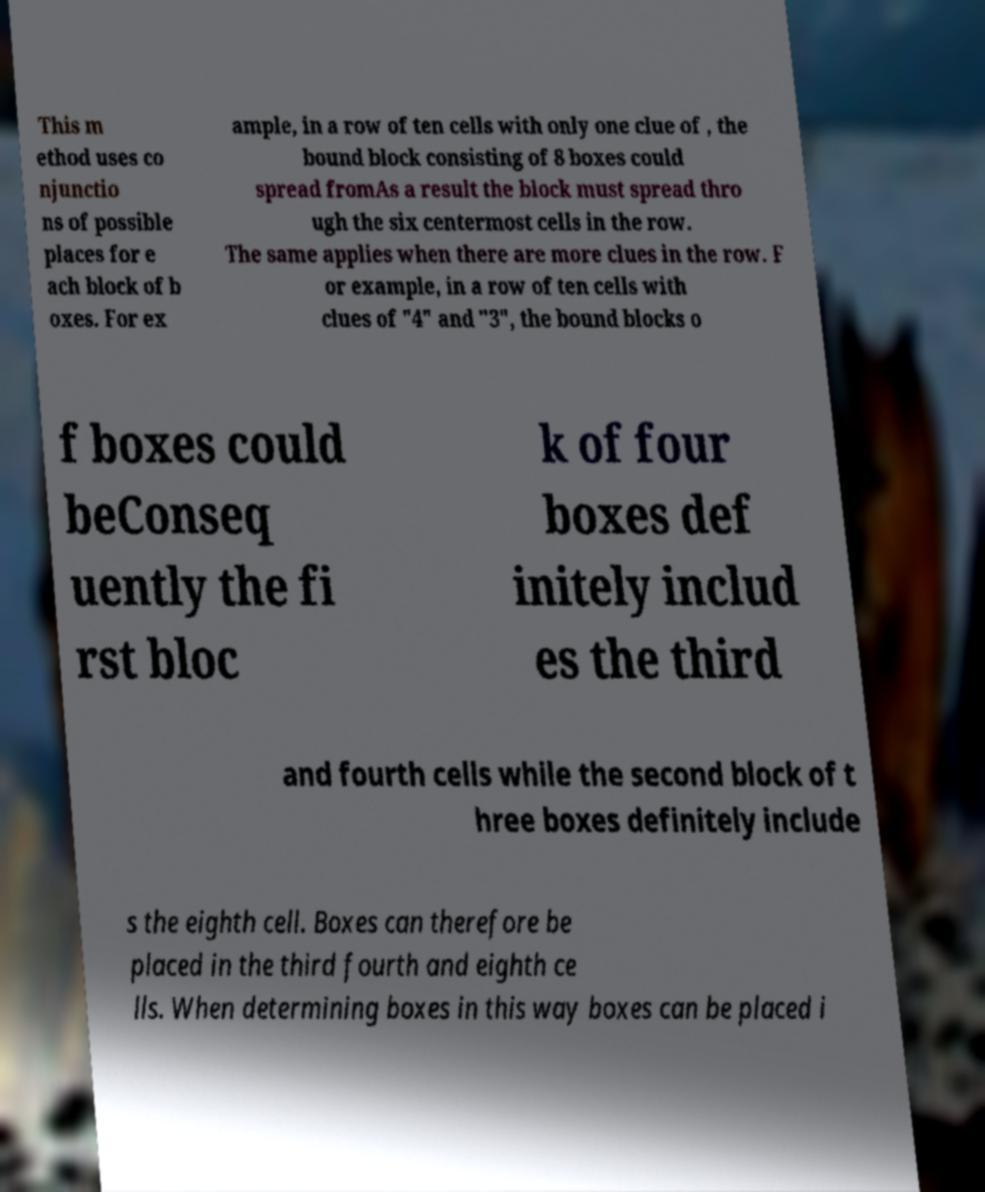What messages or text are displayed in this image? I need them in a readable, typed format. This m ethod uses co njunctio ns of possible places for e ach block of b oxes. For ex ample, in a row of ten cells with only one clue of , the bound block consisting of 8 boxes could spread fromAs a result the block must spread thro ugh the six centermost cells in the row. The same applies when there are more clues in the row. F or example, in a row of ten cells with clues of "4" and "3", the bound blocks o f boxes could beConseq uently the fi rst bloc k of four boxes def initely includ es the third and fourth cells while the second block of t hree boxes definitely include s the eighth cell. Boxes can therefore be placed in the third fourth and eighth ce lls. When determining boxes in this way boxes can be placed i 